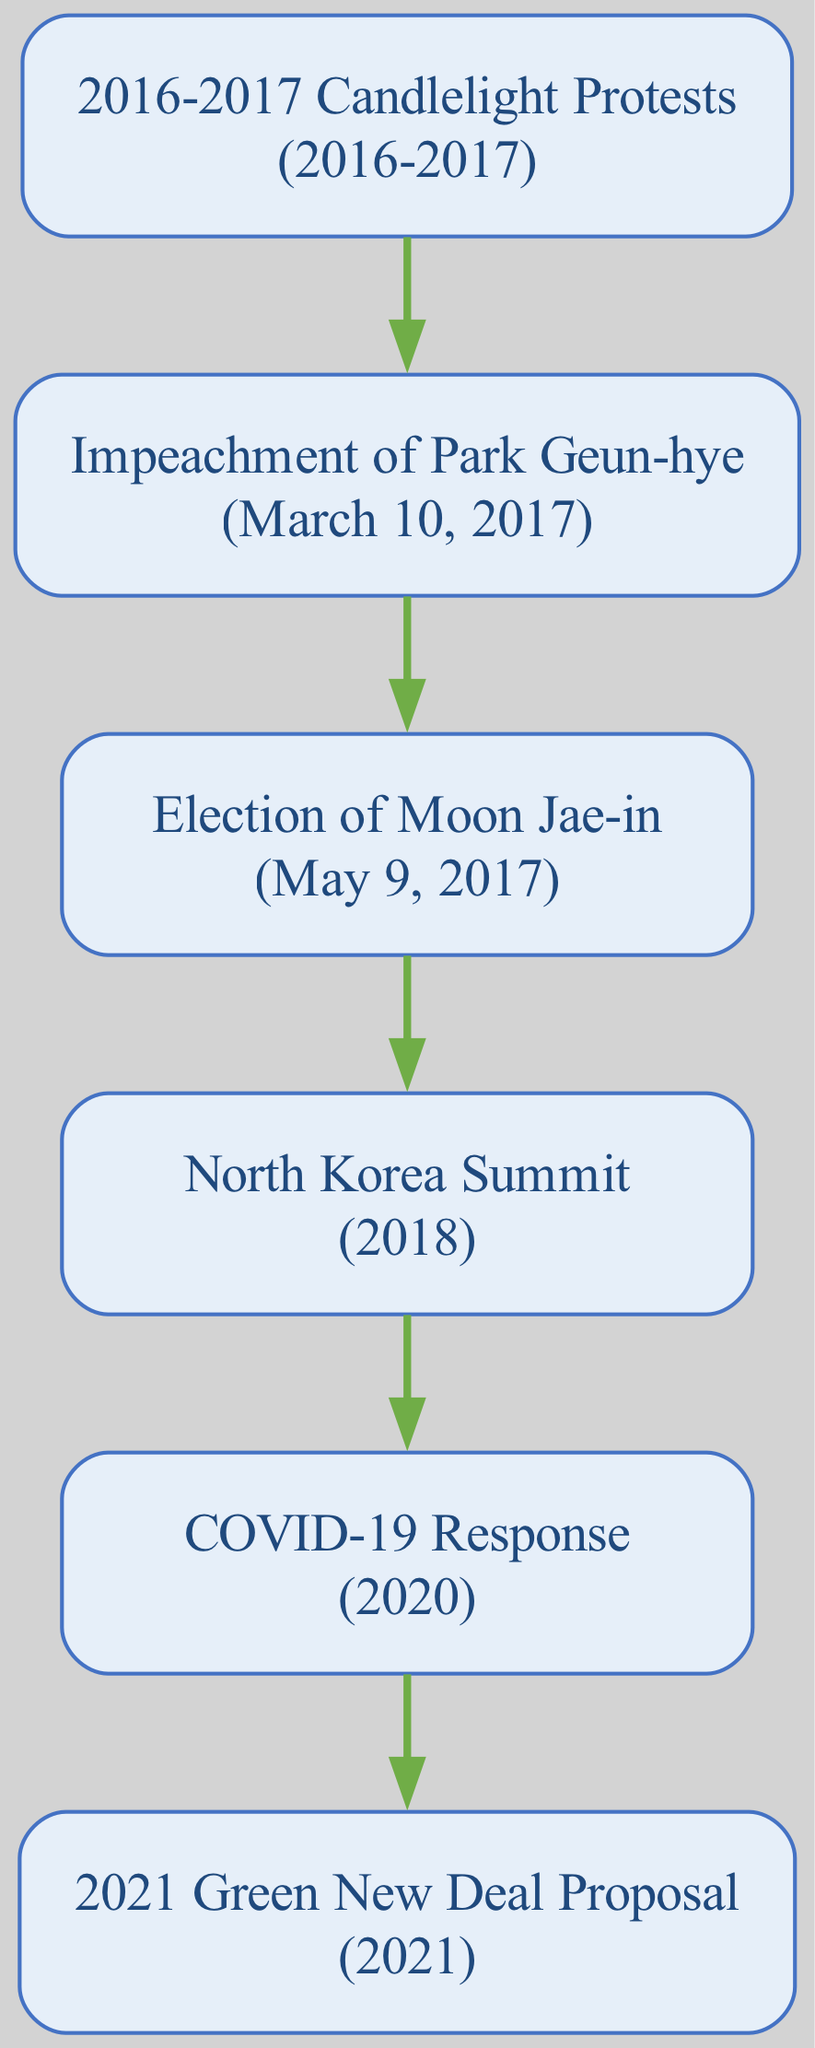What triggered the impeachment of Park Geun-hye? The impeachment was triggered by the mass protests demanding her resignation due to a corruption scandal, which started in 2016 and continued into 2017.
Answer: 2016-2017 Candlelight Protests What event follows the impeachment of Park Geun-hye? After the impeachment, the next major event in the diagram is the Election of Moon Jae-in, which took place in May 2017.
Answer: Election of Moon Jae-in How many major political events are shown in the diagram? By counting the listed events in the flow chart, we see there are a total of six major political events leading to policy changes.
Answer: 6 Which year did the Green New Deal Proposal occur? The Green New Deal Proposal is indicated in the diagram to have occurred in the year 2021.
Answer: 2021 What is the outcome of the North Korea Summit in the context of the diagram? The North Korea Summit is represented as a significant event that emphasizes President Moon Jae-in's focus on denuclearization and peace, following his election.
Answer: Peace and denuclearization What was one of the direct responses to the COVID-19 pandemic in South Korea? The diagram indicates that South Korea's rapid response to COVID-19 led to significant changes in public health policy.
Answer: Public health policy changes Which event directly follows the COVID-19 Response in the sequence? The event that directly follows the COVID-19 Response in the flow chart is the 2021 Green New Deal Proposal.
Answer: 2021 Green New Deal Proposal Which president's election resulted from the political events depicted in the diagram? The election resulting from the political events in the flow chart was that of President Moon Jae-in, elected in May 2017.
Answer: Moon Jae-in What is the significance of the 2016-2017 Candlelight Protests? The Candlelight Protests are significant as they marked a collective push by citizens for political accountability, leading to the impeachment of Park Geun-hye.
Answer: Demand for accountability 